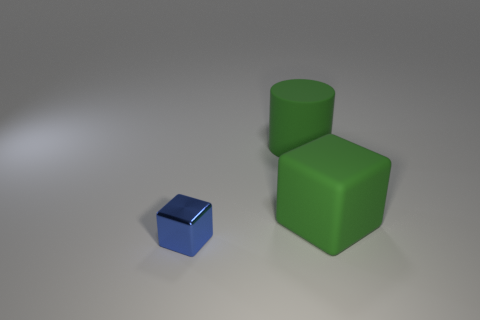Subtract all cylinders. How many objects are left? 2 Add 3 gray rubber objects. How many objects exist? 6 Subtract all purple blocks. Subtract all red balls. How many blocks are left? 2 Subtract all brown balls. How many blue cubes are left? 1 Subtract all big cyan matte objects. Subtract all cubes. How many objects are left? 1 Add 1 tiny metallic things. How many tiny metallic things are left? 2 Add 1 tiny green cylinders. How many tiny green cylinders exist? 1 Subtract 0 gray balls. How many objects are left? 3 Subtract 1 cubes. How many cubes are left? 1 